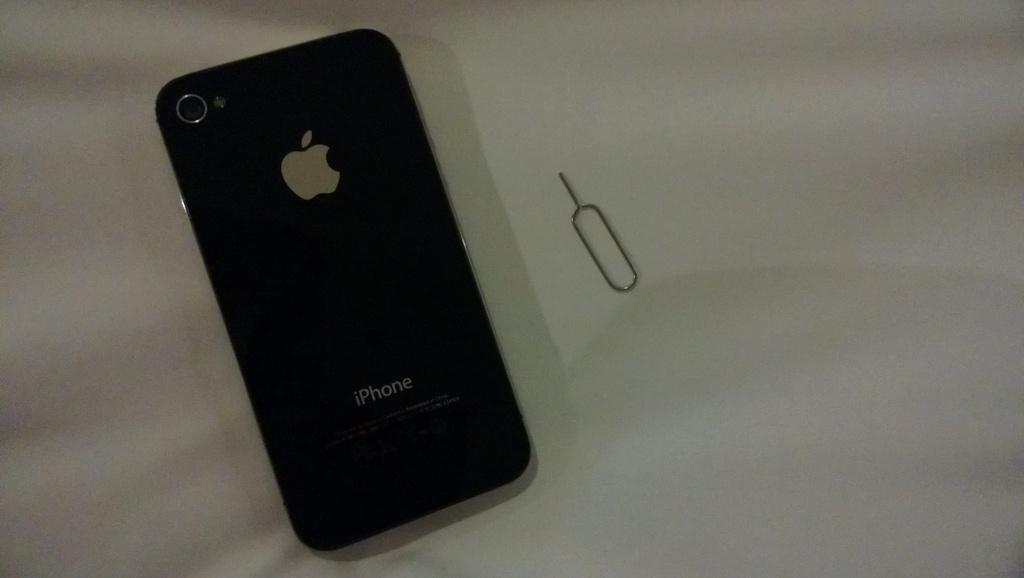<image>
Present a compact description of the photo's key features. Black iPhone next to a silver pin on a table. 